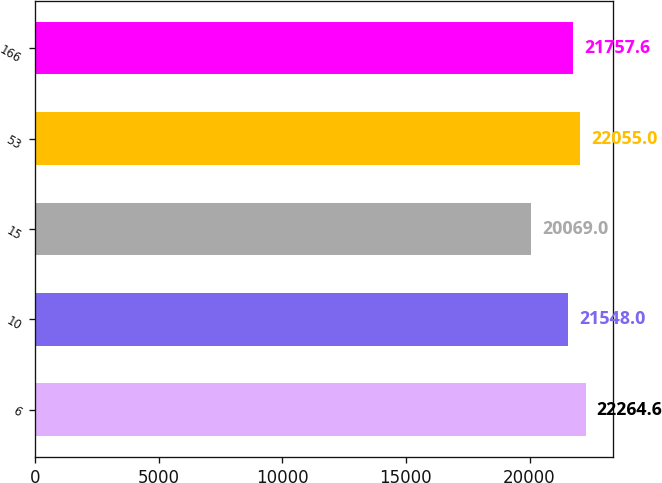Convert chart to OTSL. <chart><loc_0><loc_0><loc_500><loc_500><bar_chart><fcel>6<fcel>10<fcel>15<fcel>53<fcel>166<nl><fcel>22264.6<fcel>21548<fcel>20069<fcel>22055<fcel>21757.6<nl></chart> 